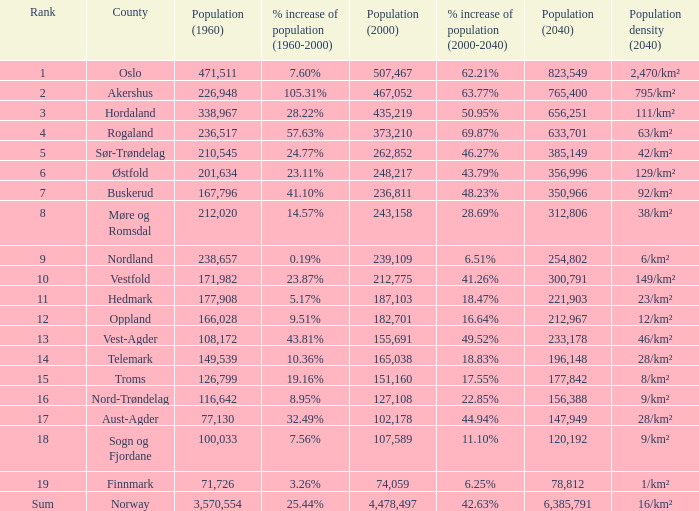What was Oslo's population in 1960, with a population of 507,467 in 2000? None. 